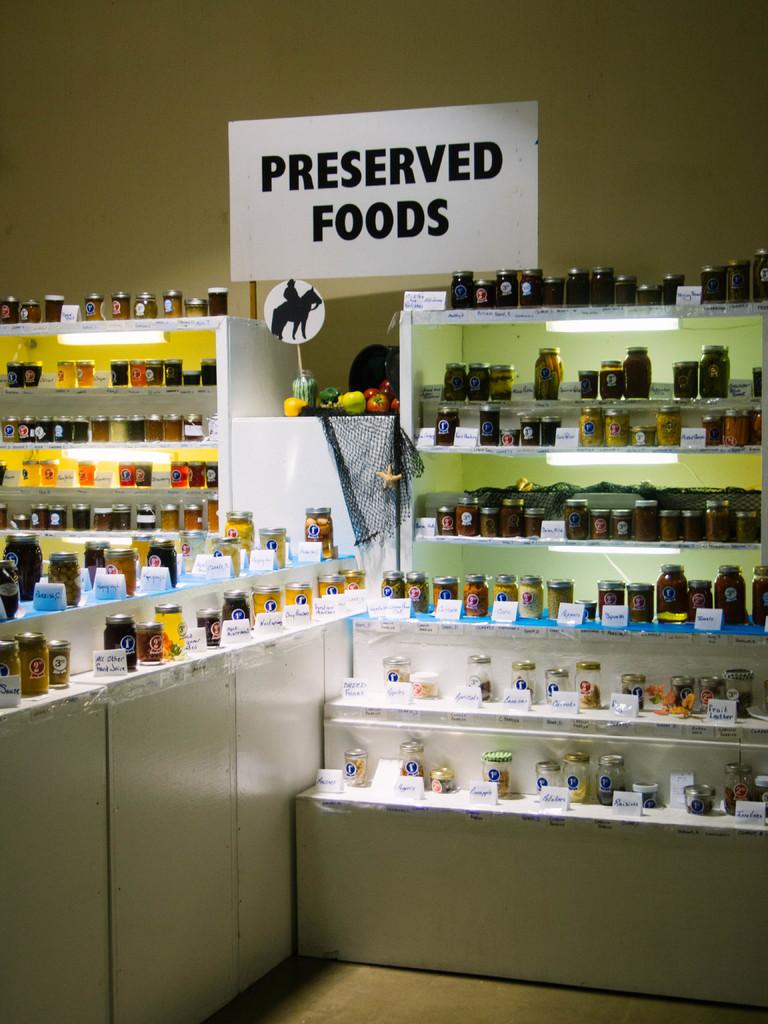What objects can be seen on the shelves in the image? There are bottles and other things on shelves in the image. What is the color of the board visible in the image? There is a white color board in the image. What is written on the white color board? Something is written on the white color board. What can be seen in the background of the image? There is a wall in the background of the image. Where are the shoes placed in the image? There are no shoes present in the image. What type of competition is taking place in the image? There is no competition present in the image. 